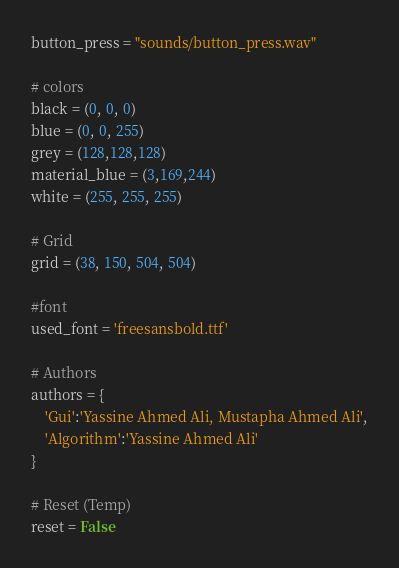Convert code to text. <code><loc_0><loc_0><loc_500><loc_500><_Python_>button_press = "sounds/button_press.wav"

# colors
black = (0, 0, 0)
blue = (0, 0, 255)
grey = (128,128,128)
material_blue = (3,169,244)
white = (255, 255, 255)

# Grid 
grid = (38, 150, 504, 504)

#font
used_font = 'freesansbold.ttf'

# Authors 
authors = {
    'Gui':'Yassine Ahmed Ali, Mustapha Ahmed Ali',
    'Algorithm':'Yassine Ahmed Ali'
}

# Reset (Temp)
reset = False
</code> 